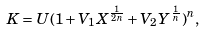<formula> <loc_0><loc_0><loc_500><loc_500>K = U ( 1 + V _ { 1 } X ^ { \frac { 1 } { 2 n } } + V _ { 2 } Y ^ { \frac { 1 } { n } } ) ^ { n } ,</formula> 